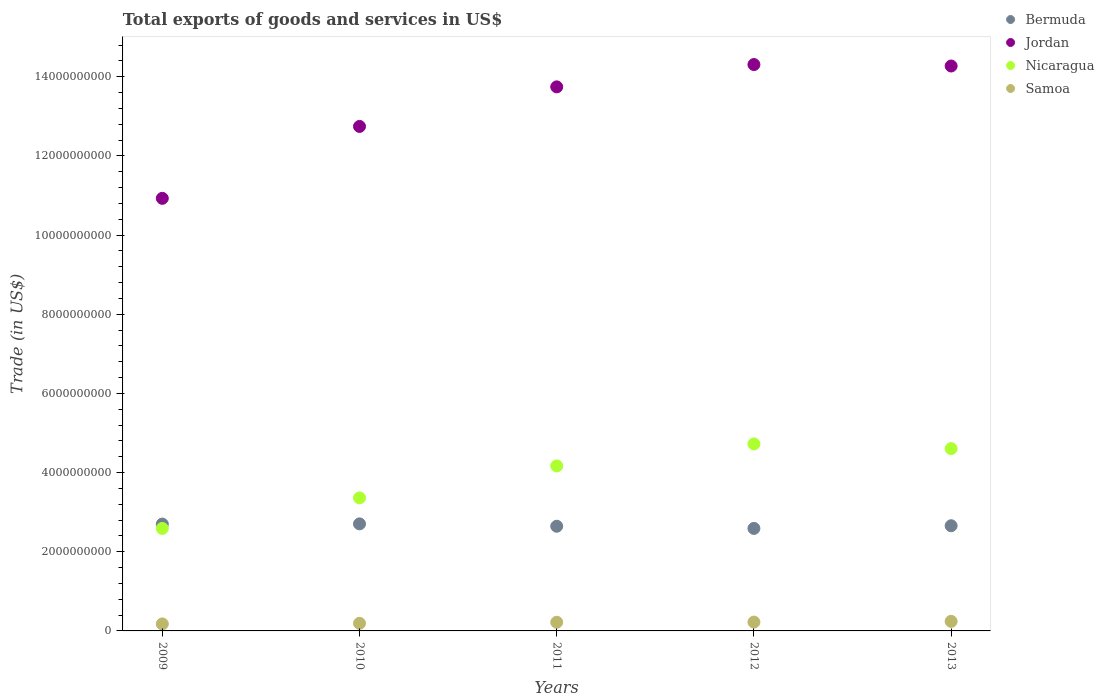How many different coloured dotlines are there?
Offer a very short reply. 4. Is the number of dotlines equal to the number of legend labels?
Offer a terse response. Yes. What is the total exports of goods and services in Jordan in 2010?
Give a very brief answer. 1.27e+1. Across all years, what is the maximum total exports of goods and services in Samoa?
Offer a very short reply. 2.41e+08. Across all years, what is the minimum total exports of goods and services in Samoa?
Your answer should be compact. 1.77e+08. What is the total total exports of goods and services in Nicaragua in the graph?
Give a very brief answer. 1.94e+1. What is the difference between the total exports of goods and services in Jordan in 2011 and that in 2013?
Your response must be concise. -5.26e+08. What is the difference between the total exports of goods and services in Jordan in 2013 and the total exports of goods and services in Samoa in 2009?
Give a very brief answer. 1.41e+1. What is the average total exports of goods and services in Jordan per year?
Ensure brevity in your answer.  1.32e+1. In the year 2011, what is the difference between the total exports of goods and services in Samoa and total exports of goods and services in Nicaragua?
Your response must be concise. -3.95e+09. In how many years, is the total exports of goods and services in Samoa greater than 5600000000 US$?
Your answer should be very brief. 0. What is the ratio of the total exports of goods and services in Samoa in 2010 to that in 2011?
Ensure brevity in your answer.  0.88. Is the total exports of goods and services in Jordan in 2009 less than that in 2010?
Ensure brevity in your answer.  Yes. Is the difference between the total exports of goods and services in Samoa in 2009 and 2010 greater than the difference between the total exports of goods and services in Nicaragua in 2009 and 2010?
Provide a succinct answer. Yes. What is the difference between the highest and the second highest total exports of goods and services in Samoa?
Make the answer very short. 1.87e+07. What is the difference between the highest and the lowest total exports of goods and services in Bermuda?
Keep it short and to the point. 1.15e+08. In how many years, is the total exports of goods and services in Jordan greater than the average total exports of goods and services in Jordan taken over all years?
Your response must be concise. 3. Is the sum of the total exports of goods and services in Bermuda in 2012 and 2013 greater than the maximum total exports of goods and services in Nicaragua across all years?
Provide a succinct answer. Yes. Is it the case that in every year, the sum of the total exports of goods and services in Nicaragua and total exports of goods and services in Samoa  is greater than the sum of total exports of goods and services in Jordan and total exports of goods and services in Bermuda?
Your answer should be compact. No. Does the total exports of goods and services in Samoa monotonically increase over the years?
Your answer should be compact. Yes. Is the total exports of goods and services in Nicaragua strictly greater than the total exports of goods and services in Jordan over the years?
Give a very brief answer. No. Is the total exports of goods and services in Bermuda strictly less than the total exports of goods and services in Nicaragua over the years?
Keep it short and to the point. No. How many dotlines are there?
Offer a very short reply. 4. How many years are there in the graph?
Provide a short and direct response. 5. What is the difference between two consecutive major ticks on the Y-axis?
Your response must be concise. 2.00e+09. Does the graph contain any zero values?
Provide a succinct answer. No. How many legend labels are there?
Ensure brevity in your answer.  4. What is the title of the graph?
Ensure brevity in your answer.  Total exports of goods and services in US$. What is the label or title of the Y-axis?
Provide a succinct answer. Trade (in US$). What is the Trade (in US$) in Bermuda in 2009?
Make the answer very short. 2.70e+09. What is the Trade (in US$) of Jordan in 2009?
Provide a succinct answer. 1.09e+1. What is the Trade (in US$) of Nicaragua in 2009?
Ensure brevity in your answer.  2.59e+09. What is the Trade (in US$) of Samoa in 2009?
Provide a short and direct response. 1.77e+08. What is the Trade (in US$) in Bermuda in 2010?
Offer a terse response. 2.70e+09. What is the Trade (in US$) of Jordan in 2010?
Your response must be concise. 1.27e+1. What is the Trade (in US$) of Nicaragua in 2010?
Provide a short and direct response. 3.36e+09. What is the Trade (in US$) in Samoa in 2010?
Provide a succinct answer. 1.92e+08. What is the Trade (in US$) of Bermuda in 2011?
Make the answer very short. 2.64e+09. What is the Trade (in US$) in Jordan in 2011?
Make the answer very short. 1.37e+1. What is the Trade (in US$) of Nicaragua in 2011?
Offer a terse response. 4.17e+09. What is the Trade (in US$) of Samoa in 2011?
Offer a very short reply. 2.19e+08. What is the Trade (in US$) in Bermuda in 2012?
Your response must be concise. 2.59e+09. What is the Trade (in US$) in Jordan in 2012?
Your answer should be very brief. 1.43e+1. What is the Trade (in US$) of Nicaragua in 2012?
Provide a short and direct response. 4.72e+09. What is the Trade (in US$) of Samoa in 2012?
Your answer should be compact. 2.23e+08. What is the Trade (in US$) in Bermuda in 2013?
Ensure brevity in your answer.  2.66e+09. What is the Trade (in US$) of Jordan in 2013?
Give a very brief answer. 1.43e+1. What is the Trade (in US$) of Nicaragua in 2013?
Your answer should be compact. 4.61e+09. What is the Trade (in US$) in Samoa in 2013?
Make the answer very short. 2.41e+08. Across all years, what is the maximum Trade (in US$) in Bermuda?
Ensure brevity in your answer.  2.70e+09. Across all years, what is the maximum Trade (in US$) of Jordan?
Offer a very short reply. 1.43e+1. Across all years, what is the maximum Trade (in US$) in Nicaragua?
Your response must be concise. 4.72e+09. Across all years, what is the maximum Trade (in US$) in Samoa?
Give a very brief answer. 2.41e+08. Across all years, what is the minimum Trade (in US$) in Bermuda?
Provide a succinct answer. 2.59e+09. Across all years, what is the minimum Trade (in US$) of Jordan?
Make the answer very short. 1.09e+1. Across all years, what is the minimum Trade (in US$) of Nicaragua?
Provide a short and direct response. 2.59e+09. Across all years, what is the minimum Trade (in US$) in Samoa?
Your response must be concise. 1.77e+08. What is the total Trade (in US$) in Bermuda in the graph?
Make the answer very short. 1.33e+1. What is the total Trade (in US$) in Jordan in the graph?
Offer a terse response. 6.60e+1. What is the total Trade (in US$) in Nicaragua in the graph?
Offer a very short reply. 1.94e+1. What is the total Trade (in US$) of Samoa in the graph?
Ensure brevity in your answer.  1.05e+09. What is the difference between the Trade (in US$) in Bermuda in 2009 and that in 2010?
Ensure brevity in your answer.  -5.34e+06. What is the difference between the Trade (in US$) of Jordan in 2009 and that in 2010?
Ensure brevity in your answer.  -1.82e+09. What is the difference between the Trade (in US$) of Nicaragua in 2009 and that in 2010?
Make the answer very short. -7.72e+08. What is the difference between the Trade (in US$) in Samoa in 2009 and that in 2010?
Offer a very short reply. -1.49e+07. What is the difference between the Trade (in US$) in Bermuda in 2009 and that in 2011?
Offer a very short reply. 5.51e+07. What is the difference between the Trade (in US$) of Jordan in 2009 and that in 2011?
Make the answer very short. -2.82e+09. What is the difference between the Trade (in US$) of Nicaragua in 2009 and that in 2011?
Provide a succinct answer. -1.58e+09. What is the difference between the Trade (in US$) in Samoa in 2009 and that in 2011?
Make the answer very short. -4.18e+07. What is the difference between the Trade (in US$) of Bermuda in 2009 and that in 2012?
Make the answer very short. 1.10e+08. What is the difference between the Trade (in US$) in Jordan in 2009 and that in 2012?
Your response must be concise. -3.38e+09. What is the difference between the Trade (in US$) in Nicaragua in 2009 and that in 2012?
Your answer should be very brief. -2.13e+09. What is the difference between the Trade (in US$) of Samoa in 2009 and that in 2012?
Offer a very short reply. -4.56e+07. What is the difference between the Trade (in US$) in Bermuda in 2009 and that in 2013?
Your answer should be very brief. 4.24e+07. What is the difference between the Trade (in US$) in Jordan in 2009 and that in 2013?
Make the answer very short. -3.34e+09. What is the difference between the Trade (in US$) in Nicaragua in 2009 and that in 2013?
Offer a very short reply. -2.02e+09. What is the difference between the Trade (in US$) in Samoa in 2009 and that in 2013?
Provide a succinct answer. -6.43e+07. What is the difference between the Trade (in US$) of Bermuda in 2010 and that in 2011?
Offer a terse response. 6.04e+07. What is the difference between the Trade (in US$) of Jordan in 2010 and that in 2011?
Your answer should be very brief. -9.99e+08. What is the difference between the Trade (in US$) in Nicaragua in 2010 and that in 2011?
Provide a short and direct response. -8.07e+08. What is the difference between the Trade (in US$) of Samoa in 2010 and that in 2011?
Your response must be concise. -2.68e+07. What is the difference between the Trade (in US$) of Bermuda in 2010 and that in 2012?
Your answer should be very brief. 1.15e+08. What is the difference between the Trade (in US$) in Jordan in 2010 and that in 2012?
Make the answer very short. -1.56e+09. What is the difference between the Trade (in US$) in Nicaragua in 2010 and that in 2012?
Your response must be concise. -1.36e+09. What is the difference between the Trade (in US$) of Samoa in 2010 and that in 2012?
Keep it short and to the point. -3.07e+07. What is the difference between the Trade (in US$) of Bermuda in 2010 and that in 2013?
Offer a terse response. 4.78e+07. What is the difference between the Trade (in US$) of Jordan in 2010 and that in 2013?
Give a very brief answer. -1.53e+09. What is the difference between the Trade (in US$) in Nicaragua in 2010 and that in 2013?
Your answer should be compact. -1.24e+09. What is the difference between the Trade (in US$) of Samoa in 2010 and that in 2013?
Your response must be concise. -4.94e+07. What is the difference between the Trade (in US$) in Bermuda in 2011 and that in 2012?
Offer a very short reply. 5.48e+07. What is the difference between the Trade (in US$) in Jordan in 2011 and that in 2012?
Give a very brief answer. -5.64e+08. What is the difference between the Trade (in US$) in Nicaragua in 2011 and that in 2012?
Give a very brief answer. -5.56e+08. What is the difference between the Trade (in US$) in Samoa in 2011 and that in 2012?
Keep it short and to the point. -3.84e+06. What is the difference between the Trade (in US$) in Bermuda in 2011 and that in 2013?
Your response must be concise. -1.27e+07. What is the difference between the Trade (in US$) in Jordan in 2011 and that in 2013?
Make the answer very short. -5.26e+08. What is the difference between the Trade (in US$) of Nicaragua in 2011 and that in 2013?
Your answer should be compact. -4.37e+08. What is the difference between the Trade (in US$) in Samoa in 2011 and that in 2013?
Keep it short and to the point. -2.25e+07. What is the difference between the Trade (in US$) in Bermuda in 2012 and that in 2013?
Make the answer very short. -6.75e+07. What is the difference between the Trade (in US$) in Jordan in 2012 and that in 2013?
Make the answer very short. 3.72e+07. What is the difference between the Trade (in US$) of Nicaragua in 2012 and that in 2013?
Keep it short and to the point. 1.19e+08. What is the difference between the Trade (in US$) in Samoa in 2012 and that in 2013?
Make the answer very short. -1.87e+07. What is the difference between the Trade (in US$) of Bermuda in 2009 and the Trade (in US$) of Jordan in 2010?
Provide a short and direct response. -1.00e+1. What is the difference between the Trade (in US$) of Bermuda in 2009 and the Trade (in US$) of Nicaragua in 2010?
Ensure brevity in your answer.  -6.62e+08. What is the difference between the Trade (in US$) in Bermuda in 2009 and the Trade (in US$) in Samoa in 2010?
Ensure brevity in your answer.  2.51e+09. What is the difference between the Trade (in US$) of Jordan in 2009 and the Trade (in US$) of Nicaragua in 2010?
Offer a terse response. 7.57e+09. What is the difference between the Trade (in US$) of Jordan in 2009 and the Trade (in US$) of Samoa in 2010?
Give a very brief answer. 1.07e+1. What is the difference between the Trade (in US$) of Nicaragua in 2009 and the Trade (in US$) of Samoa in 2010?
Make the answer very short. 2.40e+09. What is the difference between the Trade (in US$) in Bermuda in 2009 and the Trade (in US$) in Jordan in 2011?
Provide a short and direct response. -1.10e+1. What is the difference between the Trade (in US$) in Bermuda in 2009 and the Trade (in US$) in Nicaragua in 2011?
Your response must be concise. -1.47e+09. What is the difference between the Trade (in US$) in Bermuda in 2009 and the Trade (in US$) in Samoa in 2011?
Give a very brief answer. 2.48e+09. What is the difference between the Trade (in US$) of Jordan in 2009 and the Trade (in US$) of Nicaragua in 2011?
Give a very brief answer. 6.76e+09. What is the difference between the Trade (in US$) of Jordan in 2009 and the Trade (in US$) of Samoa in 2011?
Make the answer very short. 1.07e+1. What is the difference between the Trade (in US$) in Nicaragua in 2009 and the Trade (in US$) in Samoa in 2011?
Your answer should be compact. 2.37e+09. What is the difference between the Trade (in US$) in Bermuda in 2009 and the Trade (in US$) in Jordan in 2012?
Ensure brevity in your answer.  -1.16e+1. What is the difference between the Trade (in US$) of Bermuda in 2009 and the Trade (in US$) of Nicaragua in 2012?
Offer a very short reply. -2.02e+09. What is the difference between the Trade (in US$) of Bermuda in 2009 and the Trade (in US$) of Samoa in 2012?
Provide a short and direct response. 2.48e+09. What is the difference between the Trade (in US$) of Jordan in 2009 and the Trade (in US$) of Nicaragua in 2012?
Keep it short and to the point. 6.20e+09. What is the difference between the Trade (in US$) in Jordan in 2009 and the Trade (in US$) in Samoa in 2012?
Your answer should be compact. 1.07e+1. What is the difference between the Trade (in US$) of Nicaragua in 2009 and the Trade (in US$) of Samoa in 2012?
Give a very brief answer. 2.37e+09. What is the difference between the Trade (in US$) of Bermuda in 2009 and the Trade (in US$) of Jordan in 2013?
Your answer should be very brief. -1.16e+1. What is the difference between the Trade (in US$) in Bermuda in 2009 and the Trade (in US$) in Nicaragua in 2013?
Keep it short and to the point. -1.91e+09. What is the difference between the Trade (in US$) of Bermuda in 2009 and the Trade (in US$) of Samoa in 2013?
Make the answer very short. 2.46e+09. What is the difference between the Trade (in US$) in Jordan in 2009 and the Trade (in US$) in Nicaragua in 2013?
Ensure brevity in your answer.  6.32e+09. What is the difference between the Trade (in US$) of Jordan in 2009 and the Trade (in US$) of Samoa in 2013?
Make the answer very short. 1.07e+1. What is the difference between the Trade (in US$) in Nicaragua in 2009 and the Trade (in US$) in Samoa in 2013?
Make the answer very short. 2.35e+09. What is the difference between the Trade (in US$) of Bermuda in 2010 and the Trade (in US$) of Jordan in 2011?
Offer a terse response. -1.10e+1. What is the difference between the Trade (in US$) in Bermuda in 2010 and the Trade (in US$) in Nicaragua in 2011?
Give a very brief answer. -1.46e+09. What is the difference between the Trade (in US$) of Bermuda in 2010 and the Trade (in US$) of Samoa in 2011?
Your answer should be compact. 2.49e+09. What is the difference between the Trade (in US$) of Jordan in 2010 and the Trade (in US$) of Nicaragua in 2011?
Provide a succinct answer. 8.58e+09. What is the difference between the Trade (in US$) of Jordan in 2010 and the Trade (in US$) of Samoa in 2011?
Provide a short and direct response. 1.25e+1. What is the difference between the Trade (in US$) of Nicaragua in 2010 and the Trade (in US$) of Samoa in 2011?
Provide a succinct answer. 3.14e+09. What is the difference between the Trade (in US$) of Bermuda in 2010 and the Trade (in US$) of Jordan in 2012?
Make the answer very short. -1.16e+1. What is the difference between the Trade (in US$) of Bermuda in 2010 and the Trade (in US$) of Nicaragua in 2012?
Offer a very short reply. -2.02e+09. What is the difference between the Trade (in US$) in Bermuda in 2010 and the Trade (in US$) in Samoa in 2012?
Provide a succinct answer. 2.48e+09. What is the difference between the Trade (in US$) of Jordan in 2010 and the Trade (in US$) of Nicaragua in 2012?
Your answer should be very brief. 8.02e+09. What is the difference between the Trade (in US$) in Jordan in 2010 and the Trade (in US$) in Samoa in 2012?
Ensure brevity in your answer.  1.25e+1. What is the difference between the Trade (in US$) in Nicaragua in 2010 and the Trade (in US$) in Samoa in 2012?
Provide a short and direct response. 3.14e+09. What is the difference between the Trade (in US$) in Bermuda in 2010 and the Trade (in US$) in Jordan in 2013?
Give a very brief answer. -1.16e+1. What is the difference between the Trade (in US$) in Bermuda in 2010 and the Trade (in US$) in Nicaragua in 2013?
Offer a terse response. -1.90e+09. What is the difference between the Trade (in US$) in Bermuda in 2010 and the Trade (in US$) in Samoa in 2013?
Offer a very short reply. 2.46e+09. What is the difference between the Trade (in US$) in Jordan in 2010 and the Trade (in US$) in Nicaragua in 2013?
Your answer should be compact. 8.14e+09. What is the difference between the Trade (in US$) in Jordan in 2010 and the Trade (in US$) in Samoa in 2013?
Provide a succinct answer. 1.25e+1. What is the difference between the Trade (in US$) in Nicaragua in 2010 and the Trade (in US$) in Samoa in 2013?
Keep it short and to the point. 3.12e+09. What is the difference between the Trade (in US$) in Bermuda in 2011 and the Trade (in US$) in Jordan in 2012?
Your answer should be very brief. -1.17e+1. What is the difference between the Trade (in US$) of Bermuda in 2011 and the Trade (in US$) of Nicaragua in 2012?
Keep it short and to the point. -2.08e+09. What is the difference between the Trade (in US$) in Bermuda in 2011 and the Trade (in US$) in Samoa in 2012?
Keep it short and to the point. 2.42e+09. What is the difference between the Trade (in US$) in Jordan in 2011 and the Trade (in US$) in Nicaragua in 2012?
Give a very brief answer. 9.02e+09. What is the difference between the Trade (in US$) in Jordan in 2011 and the Trade (in US$) in Samoa in 2012?
Provide a short and direct response. 1.35e+1. What is the difference between the Trade (in US$) in Nicaragua in 2011 and the Trade (in US$) in Samoa in 2012?
Your answer should be compact. 3.95e+09. What is the difference between the Trade (in US$) of Bermuda in 2011 and the Trade (in US$) of Jordan in 2013?
Your answer should be very brief. -1.16e+1. What is the difference between the Trade (in US$) in Bermuda in 2011 and the Trade (in US$) in Nicaragua in 2013?
Offer a terse response. -1.96e+09. What is the difference between the Trade (in US$) in Bermuda in 2011 and the Trade (in US$) in Samoa in 2013?
Offer a terse response. 2.40e+09. What is the difference between the Trade (in US$) in Jordan in 2011 and the Trade (in US$) in Nicaragua in 2013?
Provide a short and direct response. 9.14e+09. What is the difference between the Trade (in US$) of Jordan in 2011 and the Trade (in US$) of Samoa in 2013?
Ensure brevity in your answer.  1.35e+1. What is the difference between the Trade (in US$) in Nicaragua in 2011 and the Trade (in US$) in Samoa in 2013?
Your answer should be compact. 3.93e+09. What is the difference between the Trade (in US$) in Bermuda in 2012 and the Trade (in US$) in Jordan in 2013?
Your response must be concise. -1.17e+1. What is the difference between the Trade (in US$) of Bermuda in 2012 and the Trade (in US$) of Nicaragua in 2013?
Your answer should be very brief. -2.02e+09. What is the difference between the Trade (in US$) in Bermuda in 2012 and the Trade (in US$) in Samoa in 2013?
Your answer should be very brief. 2.35e+09. What is the difference between the Trade (in US$) of Jordan in 2012 and the Trade (in US$) of Nicaragua in 2013?
Provide a succinct answer. 9.70e+09. What is the difference between the Trade (in US$) of Jordan in 2012 and the Trade (in US$) of Samoa in 2013?
Offer a terse response. 1.41e+1. What is the difference between the Trade (in US$) of Nicaragua in 2012 and the Trade (in US$) of Samoa in 2013?
Provide a succinct answer. 4.48e+09. What is the average Trade (in US$) in Bermuda per year?
Your answer should be very brief. 2.66e+09. What is the average Trade (in US$) of Jordan per year?
Provide a short and direct response. 1.32e+1. What is the average Trade (in US$) in Nicaragua per year?
Your answer should be very brief. 3.89e+09. What is the average Trade (in US$) of Samoa per year?
Offer a terse response. 2.10e+08. In the year 2009, what is the difference between the Trade (in US$) in Bermuda and Trade (in US$) in Jordan?
Your answer should be very brief. -8.23e+09. In the year 2009, what is the difference between the Trade (in US$) in Bermuda and Trade (in US$) in Nicaragua?
Keep it short and to the point. 1.10e+08. In the year 2009, what is the difference between the Trade (in US$) of Bermuda and Trade (in US$) of Samoa?
Keep it short and to the point. 2.52e+09. In the year 2009, what is the difference between the Trade (in US$) in Jordan and Trade (in US$) in Nicaragua?
Offer a terse response. 8.34e+09. In the year 2009, what is the difference between the Trade (in US$) in Jordan and Trade (in US$) in Samoa?
Make the answer very short. 1.08e+1. In the year 2009, what is the difference between the Trade (in US$) of Nicaragua and Trade (in US$) of Samoa?
Your answer should be compact. 2.41e+09. In the year 2010, what is the difference between the Trade (in US$) of Bermuda and Trade (in US$) of Jordan?
Make the answer very short. -1.00e+1. In the year 2010, what is the difference between the Trade (in US$) in Bermuda and Trade (in US$) in Nicaragua?
Give a very brief answer. -6.56e+08. In the year 2010, what is the difference between the Trade (in US$) in Bermuda and Trade (in US$) in Samoa?
Give a very brief answer. 2.51e+09. In the year 2010, what is the difference between the Trade (in US$) in Jordan and Trade (in US$) in Nicaragua?
Provide a short and direct response. 9.38e+09. In the year 2010, what is the difference between the Trade (in US$) of Jordan and Trade (in US$) of Samoa?
Offer a terse response. 1.26e+1. In the year 2010, what is the difference between the Trade (in US$) in Nicaragua and Trade (in US$) in Samoa?
Ensure brevity in your answer.  3.17e+09. In the year 2011, what is the difference between the Trade (in US$) in Bermuda and Trade (in US$) in Jordan?
Make the answer very short. -1.11e+1. In the year 2011, what is the difference between the Trade (in US$) in Bermuda and Trade (in US$) in Nicaragua?
Provide a short and direct response. -1.52e+09. In the year 2011, what is the difference between the Trade (in US$) in Bermuda and Trade (in US$) in Samoa?
Your answer should be compact. 2.43e+09. In the year 2011, what is the difference between the Trade (in US$) of Jordan and Trade (in US$) of Nicaragua?
Offer a very short reply. 9.58e+09. In the year 2011, what is the difference between the Trade (in US$) in Jordan and Trade (in US$) in Samoa?
Offer a very short reply. 1.35e+1. In the year 2011, what is the difference between the Trade (in US$) in Nicaragua and Trade (in US$) in Samoa?
Keep it short and to the point. 3.95e+09. In the year 2012, what is the difference between the Trade (in US$) in Bermuda and Trade (in US$) in Jordan?
Your response must be concise. -1.17e+1. In the year 2012, what is the difference between the Trade (in US$) of Bermuda and Trade (in US$) of Nicaragua?
Offer a very short reply. -2.13e+09. In the year 2012, what is the difference between the Trade (in US$) of Bermuda and Trade (in US$) of Samoa?
Ensure brevity in your answer.  2.37e+09. In the year 2012, what is the difference between the Trade (in US$) of Jordan and Trade (in US$) of Nicaragua?
Your answer should be very brief. 9.58e+09. In the year 2012, what is the difference between the Trade (in US$) in Jordan and Trade (in US$) in Samoa?
Provide a succinct answer. 1.41e+1. In the year 2012, what is the difference between the Trade (in US$) of Nicaragua and Trade (in US$) of Samoa?
Keep it short and to the point. 4.50e+09. In the year 2013, what is the difference between the Trade (in US$) of Bermuda and Trade (in US$) of Jordan?
Your answer should be very brief. -1.16e+1. In the year 2013, what is the difference between the Trade (in US$) of Bermuda and Trade (in US$) of Nicaragua?
Ensure brevity in your answer.  -1.95e+09. In the year 2013, what is the difference between the Trade (in US$) of Bermuda and Trade (in US$) of Samoa?
Provide a succinct answer. 2.42e+09. In the year 2013, what is the difference between the Trade (in US$) in Jordan and Trade (in US$) in Nicaragua?
Offer a very short reply. 9.67e+09. In the year 2013, what is the difference between the Trade (in US$) of Jordan and Trade (in US$) of Samoa?
Ensure brevity in your answer.  1.40e+1. In the year 2013, what is the difference between the Trade (in US$) of Nicaragua and Trade (in US$) of Samoa?
Offer a very short reply. 4.36e+09. What is the ratio of the Trade (in US$) of Bermuda in 2009 to that in 2010?
Your response must be concise. 1. What is the ratio of the Trade (in US$) of Jordan in 2009 to that in 2010?
Your answer should be very brief. 0.86. What is the ratio of the Trade (in US$) of Nicaragua in 2009 to that in 2010?
Your response must be concise. 0.77. What is the ratio of the Trade (in US$) of Samoa in 2009 to that in 2010?
Your answer should be compact. 0.92. What is the ratio of the Trade (in US$) of Bermuda in 2009 to that in 2011?
Your answer should be compact. 1.02. What is the ratio of the Trade (in US$) in Jordan in 2009 to that in 2011?
Ensure brevity in your answer.  0.8. What is the ratio of the Trade (in US$) of Nicaragua in 2009 to that in 2011?
Give a very brief answer. 0.62. What is the ratio of the Trade (in US$) in Samoa in 2009 to that in 2011?
Your response must be concise. 0.81. What is the ratio of the Trade (in US$) in Bermuda in 2009 to that in 2012?
Give a very brief answer. 1.04. What is the ratio of the Trade (in US$) in Jordan in 2009 to that in 2012?
Your response must be concise. 0.76. What is the ratio of the Trade (in US$) in Nicaragua in 2009 to that in 2012?
Ensure brevity in your answer.  0.55. What is the ratio of the Trade (in US$) in Samoa in 2009 to that in 2012?
Provide a short and direct response. 0.8. What is the ratio of the Trade (in US$) in Jordan in 2009 to that in 2013?
Keep it short and to the point. 0.77. What is the ratio of the Trade (in US$) of Nicaragua in 2009 to that in 2013?
Ensure brevity in your answer.  0.56. What is the ratio of the Trade (in US$) in Samoa in 2009 to that in 2013?
Give a very brief answer. 0.73. What is the ratio of the Trade (in US$) in Bermuda in 2010 to that in 2011?
Offer a terse response. 1.02. What is the ratio of the Trade (in US$) in Jordan in 2010 to that in 2011?
Offer a very short reply. 0.93. What is the ratio of the Trade (in US$) in Nicaragua in 2010 to that in 2011?
Your response must be concise. 0.81. What is the ratio of the Trade (in US$) of Samoa in 2010 to that in 2011?
Your response must be concise. 0.88. What is the ratio of the Trade (in US$) in Bermuda in 2010 to that in 2012?
Your response must be concise. 1.04. What is the ratio of the Trade (in US$) in Jordan in 2010 to that in 2012?
Give a very brief answer. 0.89. What is the ratio of the Trade (in US$) in Nicaragua in 2010 to that in 2012?
Provide a short and direct response. 0.71. What is the ratio of the Trade (in US$) in Samoa in 2010 to that in 2012?
Offer a terse response. 0.86. What is the ratio of the Trade (in US$) of Bermuda in 2010 to that in 2013?
Provide a succinct answer. 1.02. What is the ratio of the Trade (in US$) of Jordan in 2010 to that in 2013?
Your answer should be very brief. 0.89. What is the ratio of the Trade (in US$) of Nicaragua in 2010 to that in 2013?
Give a very brief answer. 0.73. What is the ratio of the Trade (in US$) of Samoa in 2010 to that in 2013?
Your response must be concise. 0.8. What is the ratio of the Trade (in US$) of Bermuda in 2011 to that in 2012?
Offer a terse response. 1.02. What is the ratio of the Trade (in US$) in Jordan in 2011 to that in 2012?
Your answer should be very brief. 0.96. What is the ratio of the Trade (in US$) of Nicaragua in 2011 to that in 2012?
Offer a very short reply. 0.88. What is the ratio of the Trade (in US$) in Samoa in 2011 to that in 2012?
Keep it short and to the point. 0.98. What is the ratio of the Trade (in US$) of Jordan in 2011 to that in 2013?
Keep it short and to the point. 0.96. What is the ratio of the Trade (in US$) of Nicaragua in 2011 to that in 2013?
Provide a short and direct response. 0.91. What is the ratio of the Trade (in US$) in Samoa in 2011 to that in 2013?
Make the answer very short. 0.91. What is the ratio of the Trade (in US$) in Bermuda in 2012 to that in 2013?
Offer a very short reply. 0.97. What is the ratio of the Trade (in US$) of Jordan in 2012 to that in 2013?
Provide a short and direct response. 1. What is the ratio of the Trade (in US$) in Nicaragua in 2012 to that in 2013?
Keep it short and to the point. 1.03. What is the ratio of the Trade (in US$) of Samoa in 2012 to that in 2013?
Your answer should be very brief. 0.92. What is the difference between the highest and the second highest Trade (in US$) of Bermuda?
Keep it short and to the point. 5.34e+06. What is the difference between the highest and the second highest Trade (in US$) in Jordan?
Your answer should be compact. 3.72e+07. What is the difference between the highest and the second highest Trade (in US$) in Nicaragua?
Keep it short and to the point. 1.19e+08. What is the difference between the highest and the second highest Trade (in US$) of Samoa?
Give a very brief answer. 1.87e+07. What is the difference between the highest and the lowest Trade (in US$) in Bermuda?
Keep it short and to the point. 1.15e+08. What is the difference between the highest and the lowest Trade (in US$) in Jordan?
Provide a short and direct response. 3.38e+09. What is the difference between the highest and the lowest Trade (in US$) of Nicaragua?
Your answer should be compact. 2.13e+09. What is the difference between the highest and the lowest Trade (in US$) of Samoa?
Your answer should be compact. 6.43e+07. 